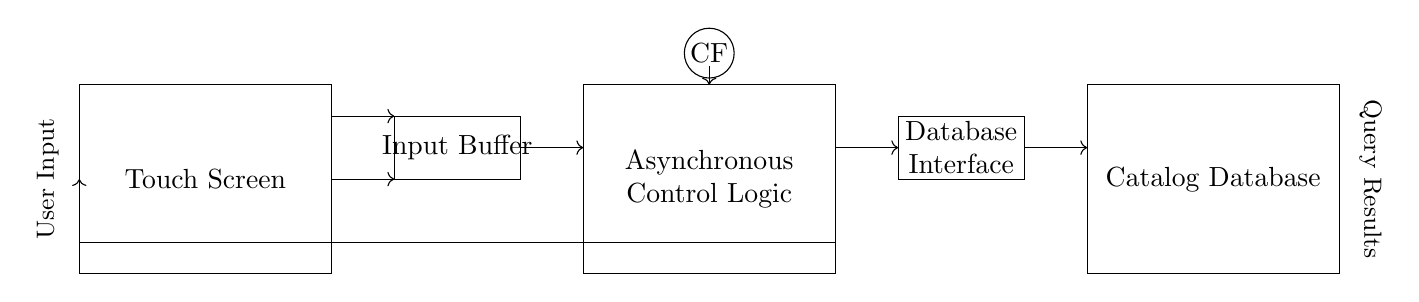What component receives user input? The Touch Screen component is responsible for receiving user input, as indicated by its label in the circuit diagram.
Answer: Touch Screen What is the function of the Input Buffer? The Input Buffer's function is to temporarily store and smooth the input signals from the Touch Screen before they are sent to the Asynchronous Control Logic.
Answer: Temporary storage How does feedback occur in this circuit? Feedback occurs through the connection from the Database Interface back to the Touch Screen, allowing the system to update the user interface based on new data.
Answer: Feedback loop What type of logic does this circuit utilize? The circuit uses asynchronous logic, as indicated by the label in the diagram, which means it does not rely on a clock signal for its operations.
Answer: Asynchronous What is the purpose of the Catalog Database? The purpose of the Catalog Database is to store the data about the library's inventory, providing the information needed when a query is received from the Database Interface.
Answer: Store data What does the symbol "CF" represent? The "CF" symbol indicates that the circuit operates without a clock signal, signifying it is a clock-free asynchronous circuit.
Answer: Clock-free 